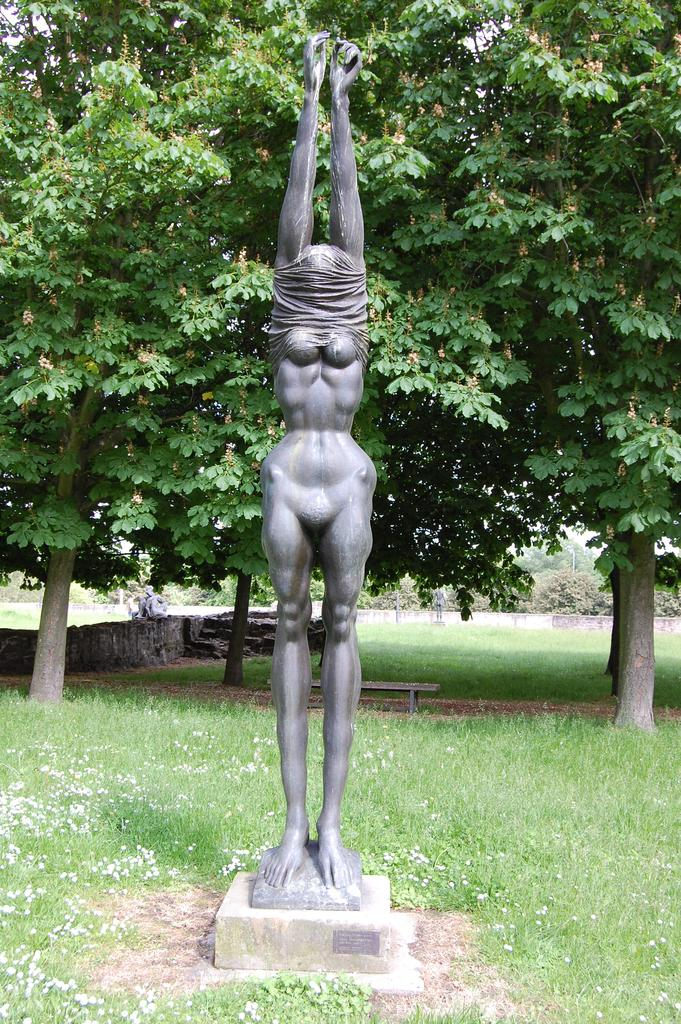What is the main subject of the image? There is a sculpture of a person standing in the image. What type of natural environment is depicted in the image? There is grass and trees in the image. What type of seating is present in the image? There is a bench in the image. What is the color of the sky in the image? The sky is white in the image. How many letters are being delivered to the flock of birds in the image? There are no birds or letters present in the image. 